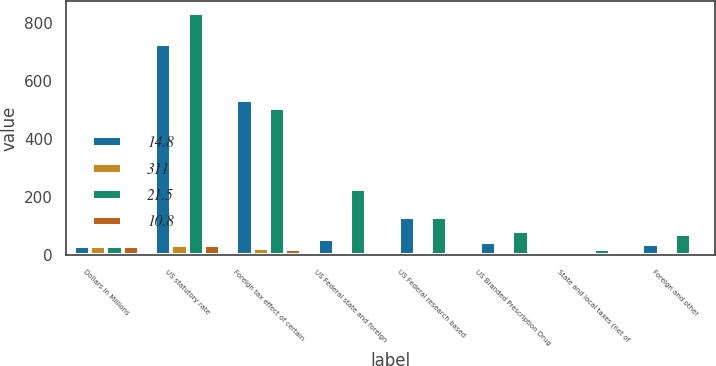Convert chart to OTSL. <chart><loc_0><loc_0><loc_500><loc_500><stacked_bar_chart><ecel><fcel>Dollars in Millions<fcel>US statutory rate<fcel>Foreign tax effect of certain<fcel>US Federal state and foreign<fcel>US Federal research based<fcel>US Branded Prescription Drug<fcel>State and local taxes (net of<fcel>Foreign and other<nl><fcel>14.8<fcel>30.4<fcel>727<fcel>535<fcel>56<fcel>132<fcel>44<fcel>16<fcel>40<nl><fcel>311<fcel>30.4<fcel>35<fcel>25.8<fcel>2.7<fcel>6.4<fcel>2.1<fcel>0.8<fcel>1.9<nl><fcel>21.5<fcel>30.4<fcel>833<fcel>509<fcel>228<fcel>131<fcel>84<fcel>20<fcel>74<nl><fcel>10.8<fcel>30.4<fcel>35<fcel>21.4<fcel>9.6<fcel>5.4<fcel>3.5<fcel>0.8<fcel>3.1<nl></chart> 